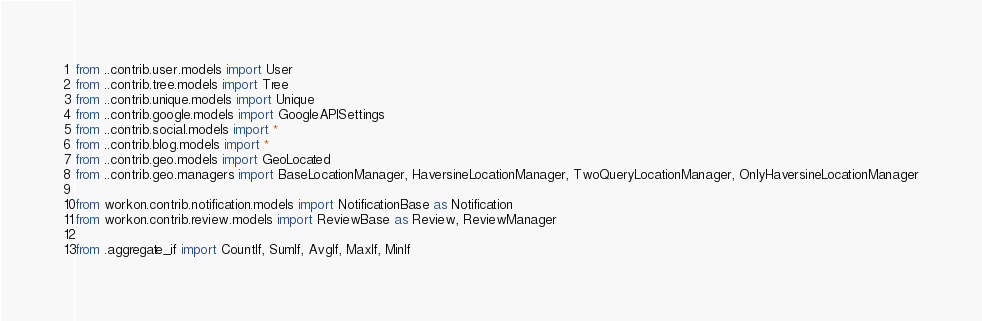<code> <loc_0><loc_0><loc_500><loc_500><_Python_>
from ..contrib.user.models import User
from ..contrib.tree.models import Tree
from ..contrib.unique.models import Unique
from ..contrib.google.models import GoogleAPISettings
from ..contrib.social.models import *
from ..contrib.blog.models import *
from ..contrib.geo.models import GeoLocated
from ..contrib.geo.managers import BaseLocationManager, HaversineLocationManager, TwoQueryLocationManager, OnlyHaversineLocationManager

from workon.contrib.notification.models import NotificationBase as Notification
from workon.contrib.review.models import ReviewBase as Review, ReviewManager

from .aggregate_if import CountIf, SumIf, AvgIf, MaxIf, MinIf
</code> 